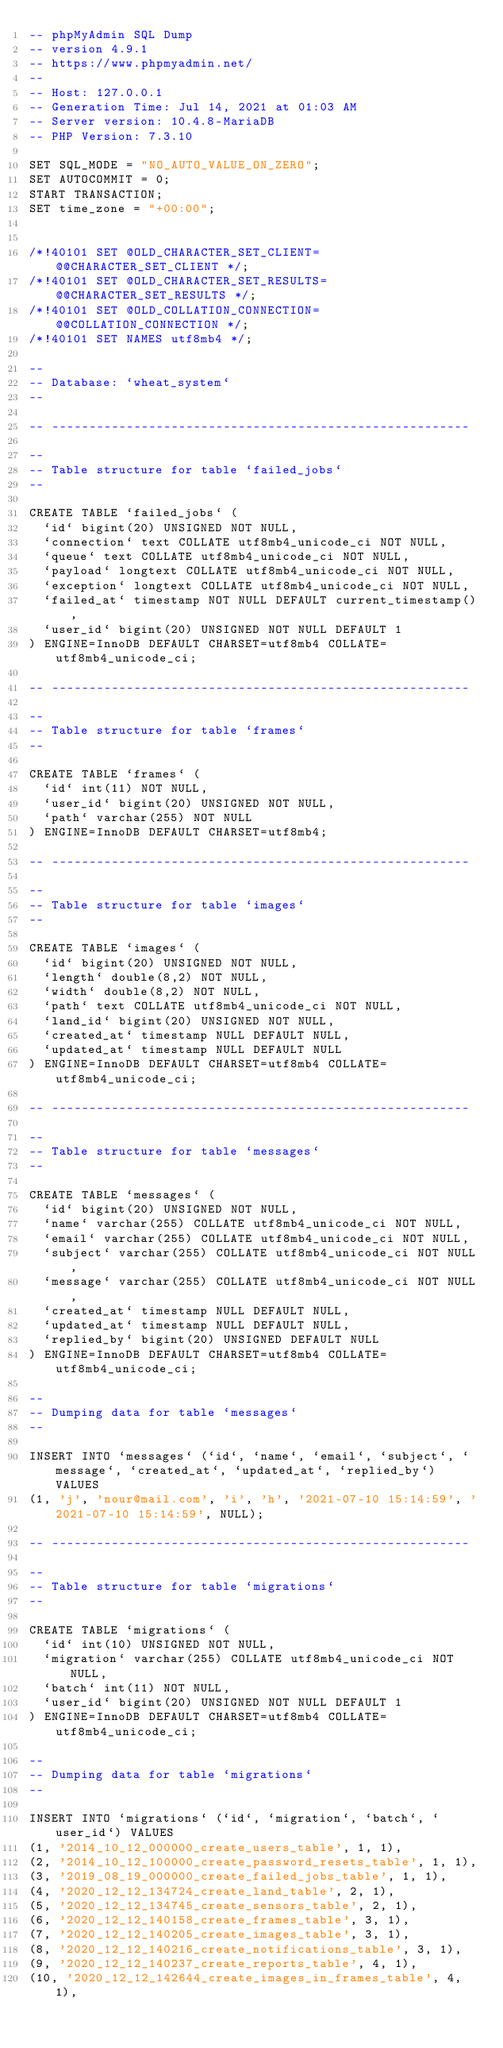<code> <loc_0><loc_0><loc_500><loc_500><_SQL_>-- phpMyAdmin SQL Dump
-- version 4.9.1
-- https://www.phpmyadmin.net/
--
-- Host: 127.0.0.1
-- Generation Time: Jul 14, 2021 at 01:03 AM
-- Server version: 10.4.8-MariaDB
-- PHP Version: 7.3.10

SET SQL_MODE = "NO_AUTO_VALUE_ON_ZERO";
SET AUTOCOMMIT = 0;
START TRANSACTION;
SET time_zone = "+00:00";


/*!40101 SET @OLD_CHARACTER_SET_CLIENT=@@CHARACTER_SET_CLIENT */;
/*!40101 SET @OLD_CHARACTER_SET_RESULTS=@@CHARACTER_SET_RESULTS */;
/*!40101 SET @OLD_COLLATION_CONNECTION=@@COLLATION_CONNECTION */;
/*!40101 SET NAMES utf8mb4 */;

--
-- Database: `wheat_system`
--

-- --------------------------------------------------------

--
-- Table structure for table `failed_jobs`
--

CREATE TABLE `failed_jobs` (
  `id` bigint(20) UNSIGNED NOT NULL,
  `connection` text COLLATE utf8mb4_unicode_ci NOT NULL,
  `queue` text COLLATE utf8mb4_unicode_ci NOT NULL,
  `payload` longtext COLLATE utf8mb4_unicode_ci NOT NULL,
  `exception` longtext COLLATE utf8mb4_unicode_ci NOT NULL,
  `failed_at` timestamp NOT NULL DEFAULT current_timestamp(),
  `user_id` bigint(20) UNSIGNED NOT NULL DEFAULT 1
) ENGINE=InnoDB DEFAULT CHARSET=utf8mb4 COLLATE=utf8mb4_unicode_ci;

-- --------------------------------------------------------

--
-- Table structure for table `frames`
--

CREATE TABLE `frames` (
  `id` int(11) NOT NULL,
  `user_id` bigint(20) UNSIGNED NOT NULL,
  `path` varchar(255) NOT NULL
) ENGINE=InnoDB DEFAULT CHARSET=utf8mb4;

-- --------------------------------------------------------

--
-- Table structure for table `images`
--

CREATE TABLE `images` (
  `id` bigint(20) UNSIGNED NOT NULL,
  `length` double(8,2) NOT NULL,
  `width` double(8,2) NOT NULL,
  `path` text COLLATE utf8mb4_unicode_ci NOT NULL,
  `land_id` bigint(20) UNSIGNED NOT NULL,
  `created_at` timestamp NULL DEFAULT NULL,
  `updated_at` timestamp NULL DEFAULT NULL
) ENGINE=InnoDB DEFAULT CHARSET=utf8mb4 COLLATE=utf8mb4_unicode_ci;

-- --------------------------------------------------------

--
-- Table structure for table `messages`
--

CREATE TABLE `messages` (
  `id` bigint(20) UNSIGNED NOT NULL,
  `name` varchar(255) COLLATE utf8mb4_unicode_ci NOT NULL,
  `email` varchar(255) COLLATE utf8mb4_unicode_ci NOT NULL,
  `subject` varchar(255) COLLATE utf8mb4_unicode_ci NOT NULL,
  `message` varchar(255) COLLATE utf8mb4_unicode_ci NOT NULL,
  `created_at` timestamp NULL DEFAULT NULL,
  `updated_at` timestamp NULL DEFAULT NULL,
  `replied_by` bigint(20) UNSIGNED DEFAULT NULL
) ENGINE=InnoDB DEFAULT CHARSET=utf8mb4 COLLATE=utf8mb4_unicode_ci;

--
-- Dumping data for table `messages`
--

INSERT INTO `messages` (`id`, `name`, `email`, `subject`, `message`, `created_at`, `updated_at`, `replied_by`) VALUES
(1, 'j', 'nour@mail.com', 'i', 'h', '2021-07-10 15:14:59', '2021-07-10 15:14:59', NULL);

-- --------------------------------------------------------

--
-- Table structure for table `migrations`
--

CREATE TABLE `migrations` (
  `id` int(10) UNSIGNED NOT NULL,
  `migration` varchar(255) COLLATE utf8mb4_unicode_ci NOT NULL,
  `batch` int(11) NOT NULL,
  `user_id` bigint(20) UNSIGNED NOT NULL DEFAULT 1
) ENGINE=InnoDB DEFAULT CHARSET=utf8mb4 COLLATE=utf8mb4_unicode_ci;

--
-- Dumping data for table `migrations`
--

INSERT INTO `migrations` (`id`, `migration`, `batch`, `user_id`) VALUES
(1, '2014_10_12_000000_create_users_table', 1, 1),
(2, '2014_10_12_100000_create_password_resets_table', 1, 1),
(3, '2019_08_19_000000_create_failed_jobs_table', 1, 1),
(4, '2020_12_12_134724_create_land_table', 2, 1),
(5, '2020_12_12_134745_create_sensors_table', 2, 1),
(6, '2020_12_12_140158_create_frames_table', 3, 1),
(7, '2020_12_12_140205_create_images_table', 3, 1),
(8, '2020_12_12_140216_create_notifications_table', 3, 1),
(9, '2020_12_12_140237_create_reports_table', 4, 1),
(10, '2020_12_12_142644_create_images_in_frames_table', 4, 1),</code> 